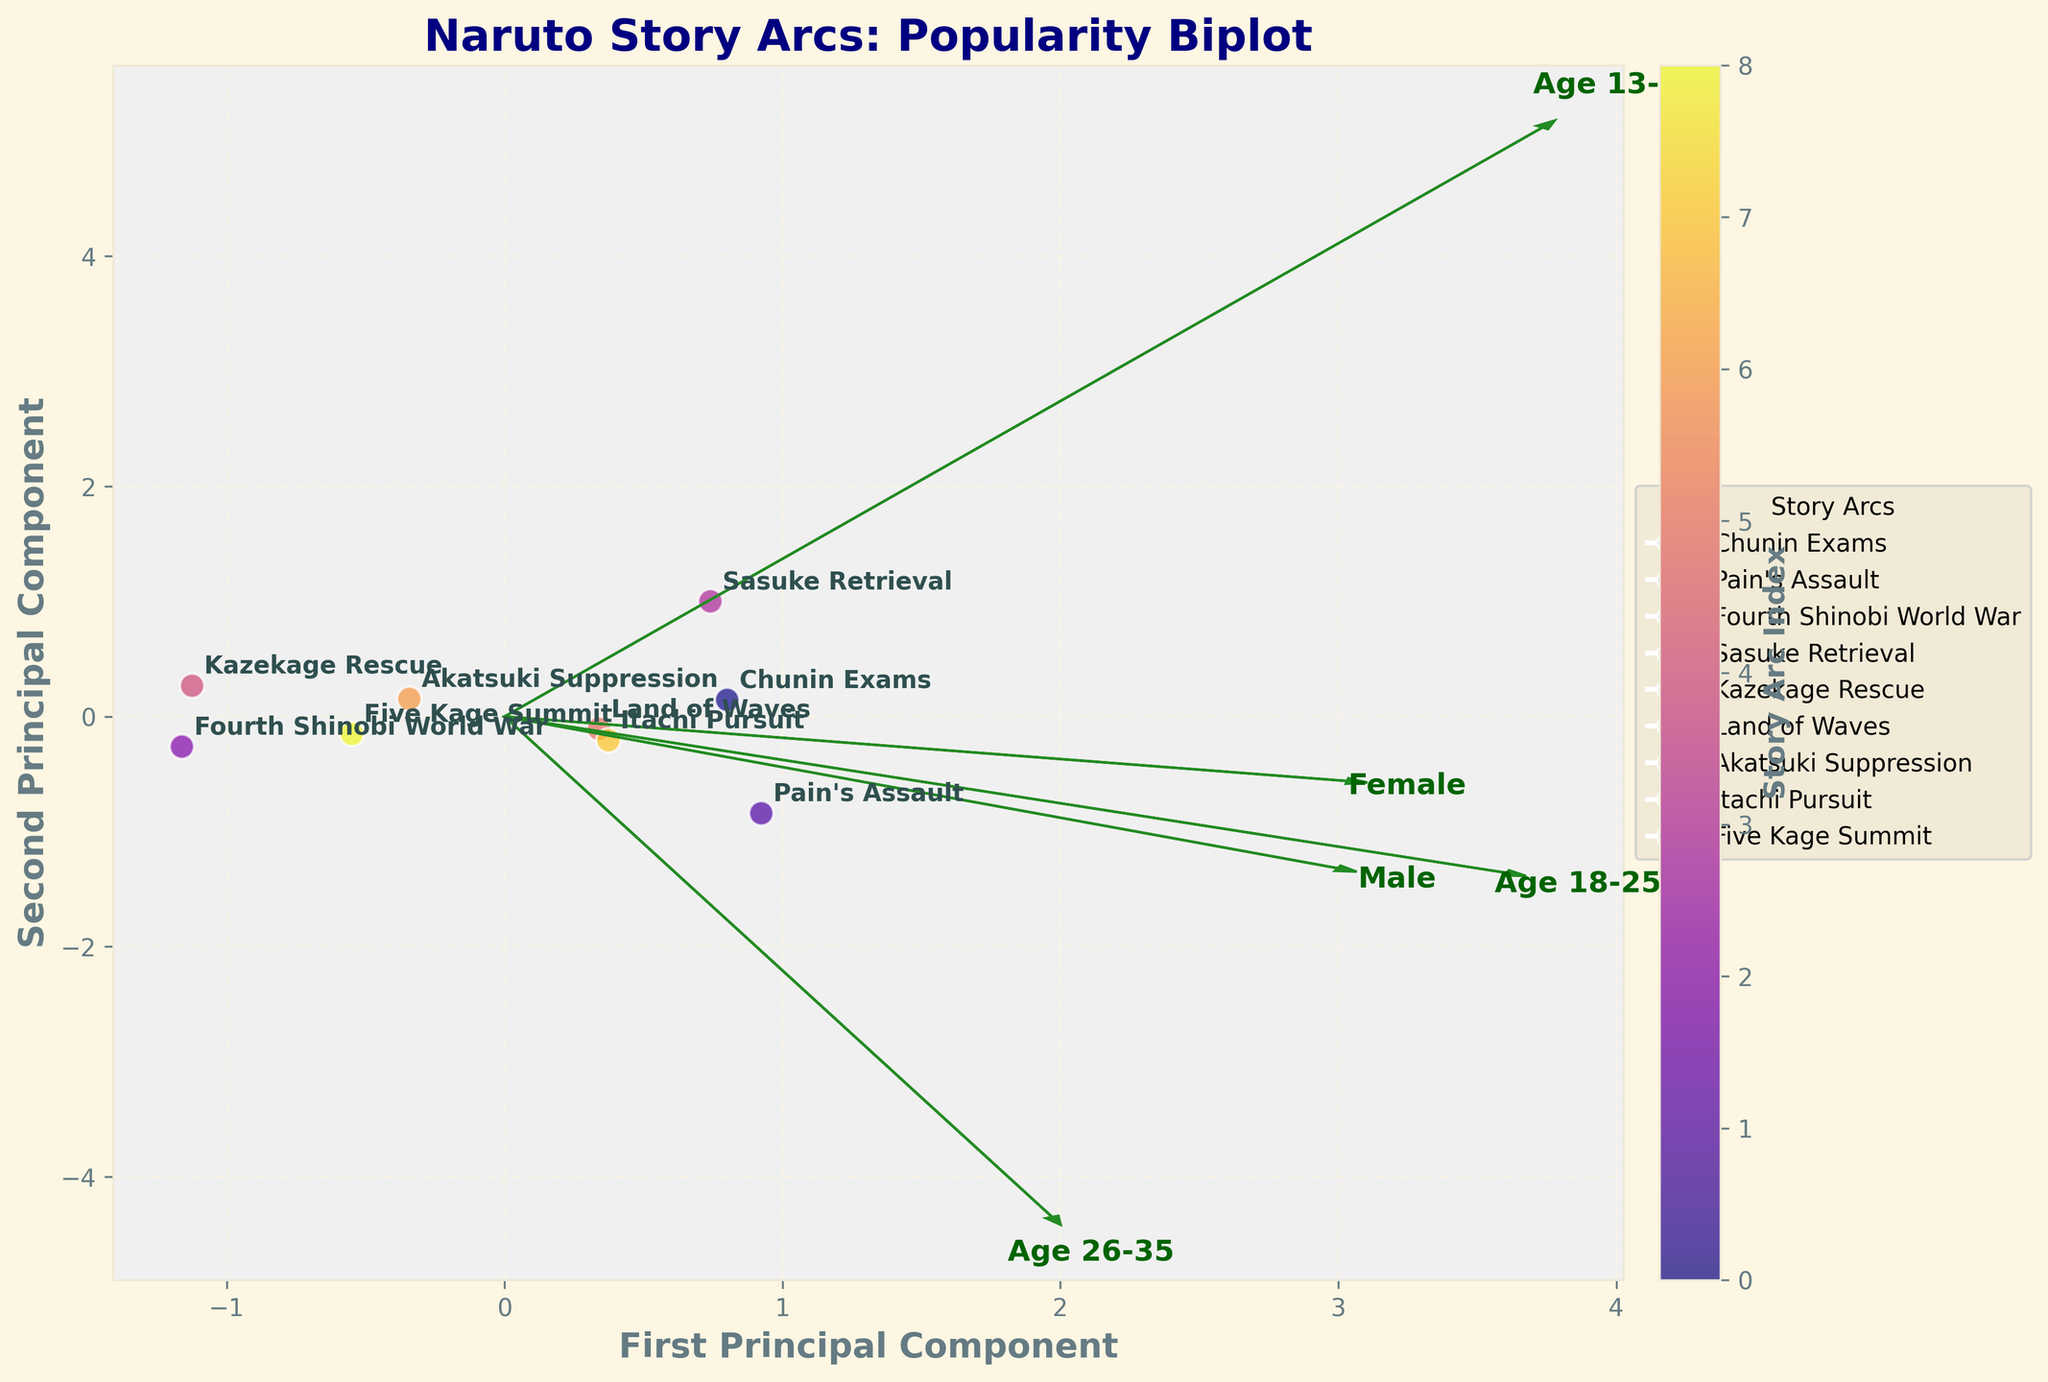What is the overall title of the plot? The title of the plot is written at the top of the figure. It provides a quick summary of what the plot represents. By looking at the title, we can know that it is a "Naruto Story Arcs: Popularity Biplot."
Answer: Naruto Story Arcs: Popularity Biplot Which story arc has the highest overall popularity score? To determine the highest overall popularity score, you need to locate the data point that represents the highest overall popularity value. The "Pain's Assault" arc has the highest overall popularity score in the dataset.
Answer: Pain's Assault Which principal component represents the maximum variance in the data? In a PCA plot, the x-axis usually represents the first principal component, which accounts for the maximum variance in the data. Thus, the x-axis represents the first principal component.
Answer: First Principal Component How many story arcs are represented in the plot? Each data point on the plot corresponds to a story arc. By counting the data points or the labels annotated on the plot, we can determine the number of story arcs. There are 9 arcs in total.
Answer: 9 Which story arc is closest to the center of the plot and what might that indicate? By looking at the plot, the data point for the "Kazekage Rescue" arc appears to be closest to the center. This suggests that its popularity scores are relatively average across the demographics compared to other arcs.
Answer: Kazekage Rescue How do the popularity scores of "Sasuke Retrieval" compare across different age groups? By following the arrows and feature vectors labeled with age groups, we can trace back to where the "Sasuke Retrieval" arc is placed. It appears to have relatively high scores among "Age 13-17" and "Age 18-25", but slightly lower among "Age 26-35".
Answer: Higher among younger age groups, slightly lower among older Which demographic factors have the largest influence on the second principal component? The second principal component is represented by the y-axis. By looking at the direction and length of the vectors corresponding to the demographic factors (e.g., age, gender), we can discern which factor has a larger influence. "Age 13-17" and "Female" appear to have substantial vectors contributing to the second principal component.
Answer: Age 13-17 and Female Between "Chunin Exams" and "Fourth Shinobi World War," which arc has a higher influence on male viewers? By checking the positions in relation to the "Male" vector, it can be seen that the "Chunin Exams" is placed more closely aligned with the "Male" vector compared to the "Fourth Shinobi World War". This suggests a higher influence on male viewers for "Chunin Exams."
Answer: Chunin Exams Which factor correlates most closely with the "Itachi Pursuit" arc based on vector directions? To find out the correlation, we need to compare the position of "Itachi Pursuit" with the direction of the vectors. The arc "Itachi Pursuit" is closest to the vector direction labeled "Age 18-25," indicating a strong correlation with this age group.
Answer: Age 18-25 What does the color gradient represent in this plot? The plot legend and color bar indicate what the color gradient represents. It shows the index of story arcs, allowing for differentiation between the arcs. The color transitions from one side of the gradient to another to help identify individual arcs.
Answer: Story Arc Index 